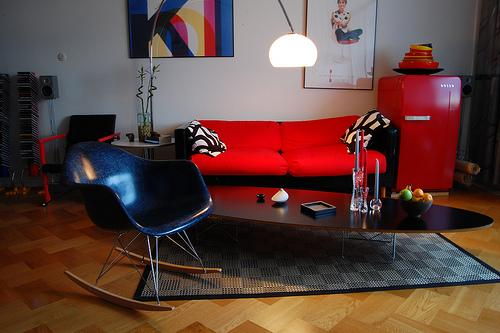Describe the objects placed on the refrigerator. There are bowls stacked on top of the refrigerator. What kind of floor is in this room and what color is the rug? The floor is brown hardwood flooring and the rug is black and beige. What is the color and shape of the table in front of the couch? The table is oval shaped and black. Tell me the sentiment of the room based on the interior and objects present. The room has a cozy and comfortable atmosphere with warm colors and a variety of seating options. How many pillows are on the sofa and what are their colors? There are two pillows on the sofa, one is red and black and the other is unspecified. What type of seating options are available in this room? A red leather sofa, a blue rocking chair, and a red and black couch. What type of fruit bowl is on the table and what is its color? A dark colored round fruit bowl. List all items related to music or entertainment in the image. CDs against the wall and a speaker attached to the wall. Identify the main pieces of furniture in the image and their colors. A red leather sofa, a blue rocking chair, a black table, and a small red refrigerator. Mention the types of wall decorations in the image. A picture, an abstract painting, and a framed picture. Do you notice an interesting pattern on the wallpaper just behind the couch? There is no mention of wallpaper or patterns on the wall in any of the image information. As a result, this instruction is misleading. Take a peek at the tall bookshelf on the far side of the room, it's really packed with books! None of the given image information includes a tall bookshelf or any books. Hence, this instruction is misleading. Please point out the fluffy white dog that's resting on the rug. There is no mention of a dog or any other pet in the provided image information. Thus, this instruction is misleading. Admire the crystal chandelier hanging from the ceiling over the table. There isn't any reference to a chandelier in the given image information. Therefore, this instruction is misleading. How comfortable does that brown leather armchair in the corner look? The image information does not include a brown leather armchair or any other furniture in the corner. Consequently, this instruction is misleading. Can you find the green potted plant near the window in the image? There is no mention of a green potted plant or a window in any of the given image information. Therefore, this instruction is misleading. 